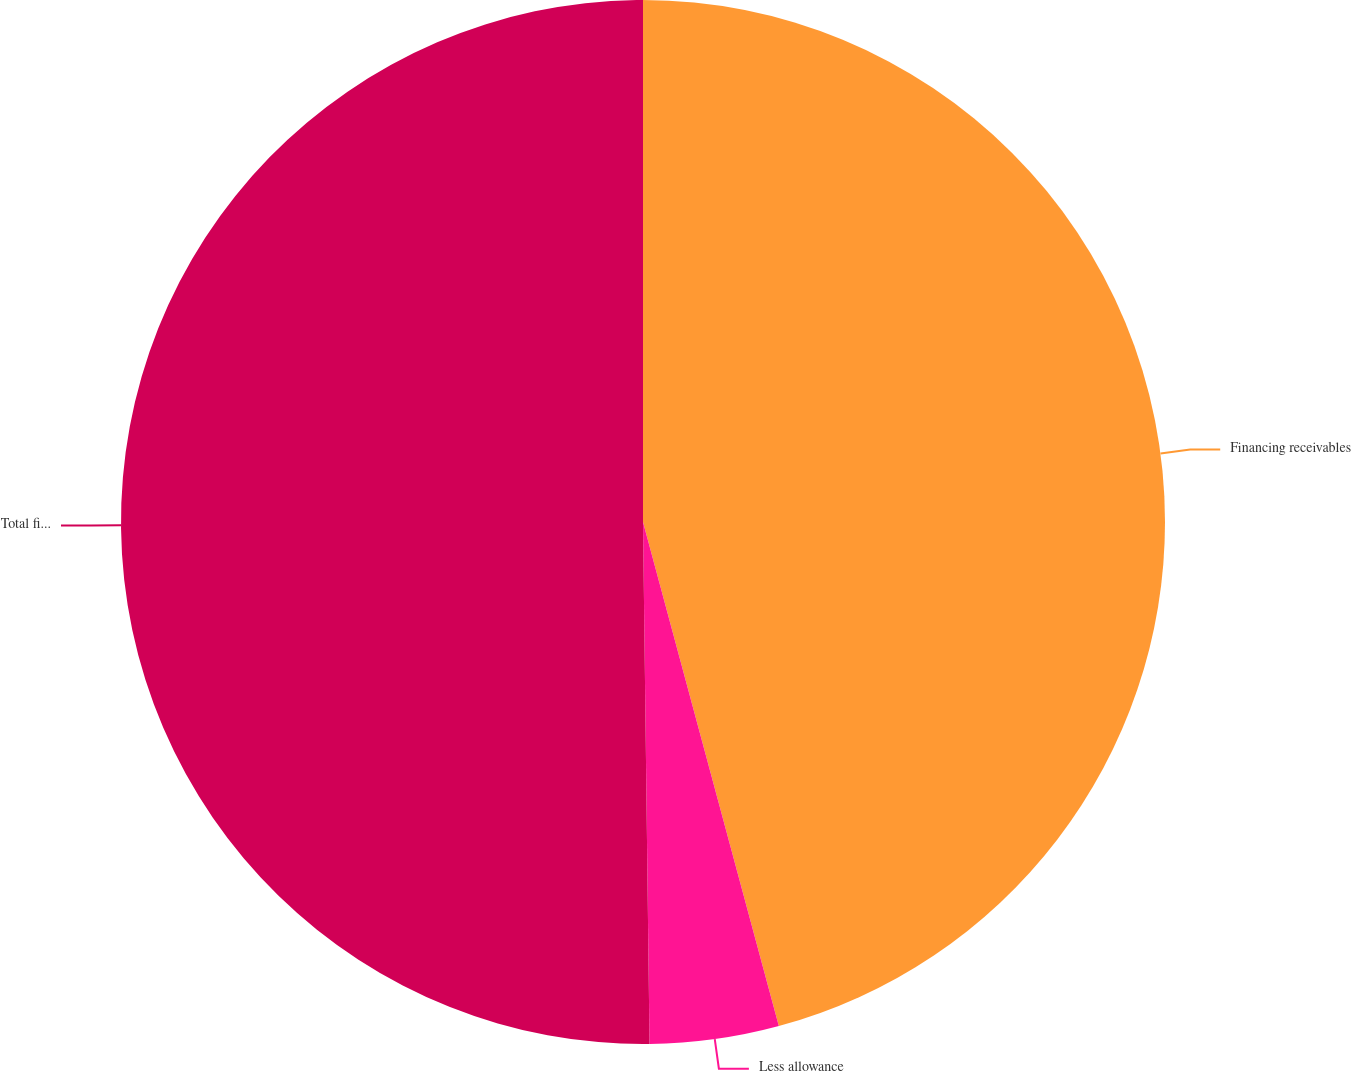<chart> <loc_0><loc_0><loc_500><loc_500><pie_chart><fcel>Financing receivables<fcel>Less allowance<fcel>Total financing receivables<nl><fcel>45.81%<fcel>3.99%<fcel>50.2%<nl></chart> 